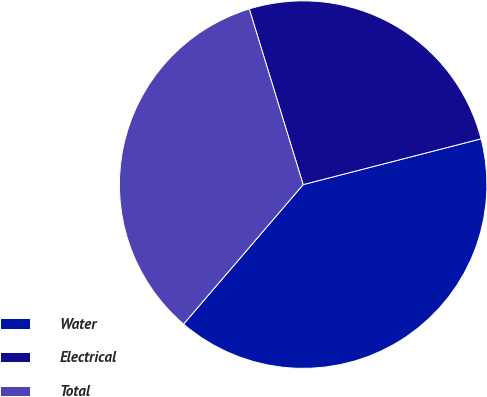<chart> <loc_0><loc_0><loc_500><loc_500><pie_chart><fcel>Water<fcel>Electrical<fcel>Total<nl><fcel>40.29%<fcel>25.73%<fcel>33.98%<nl></chart> 